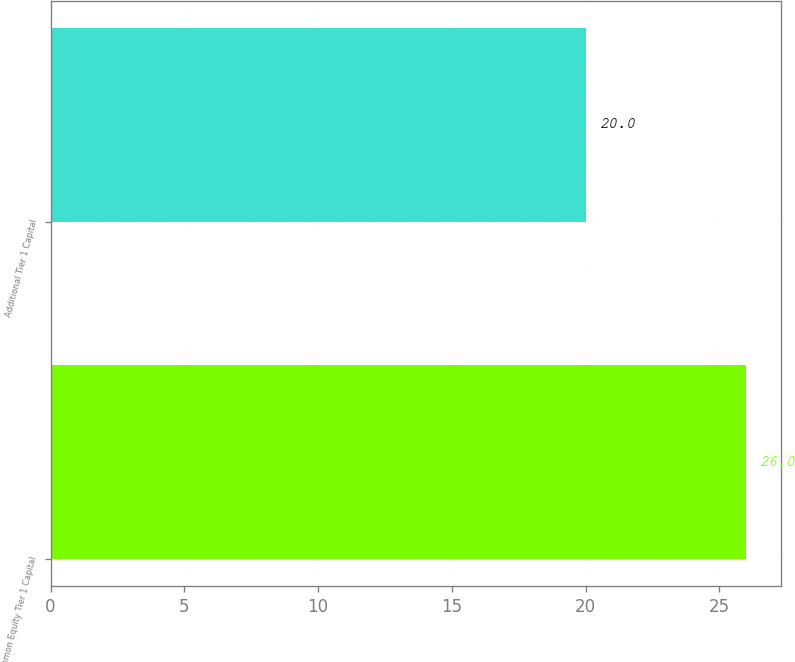Convert chart to OTSL. <chart><loc_0><loc_0><loc_500><loc_500><bar_chart><fcel>Common Equity Tier 1 Capital<fcel>Additional Tier 1 Capital<nl><fcel>26<fcel>20<nl></chart> 